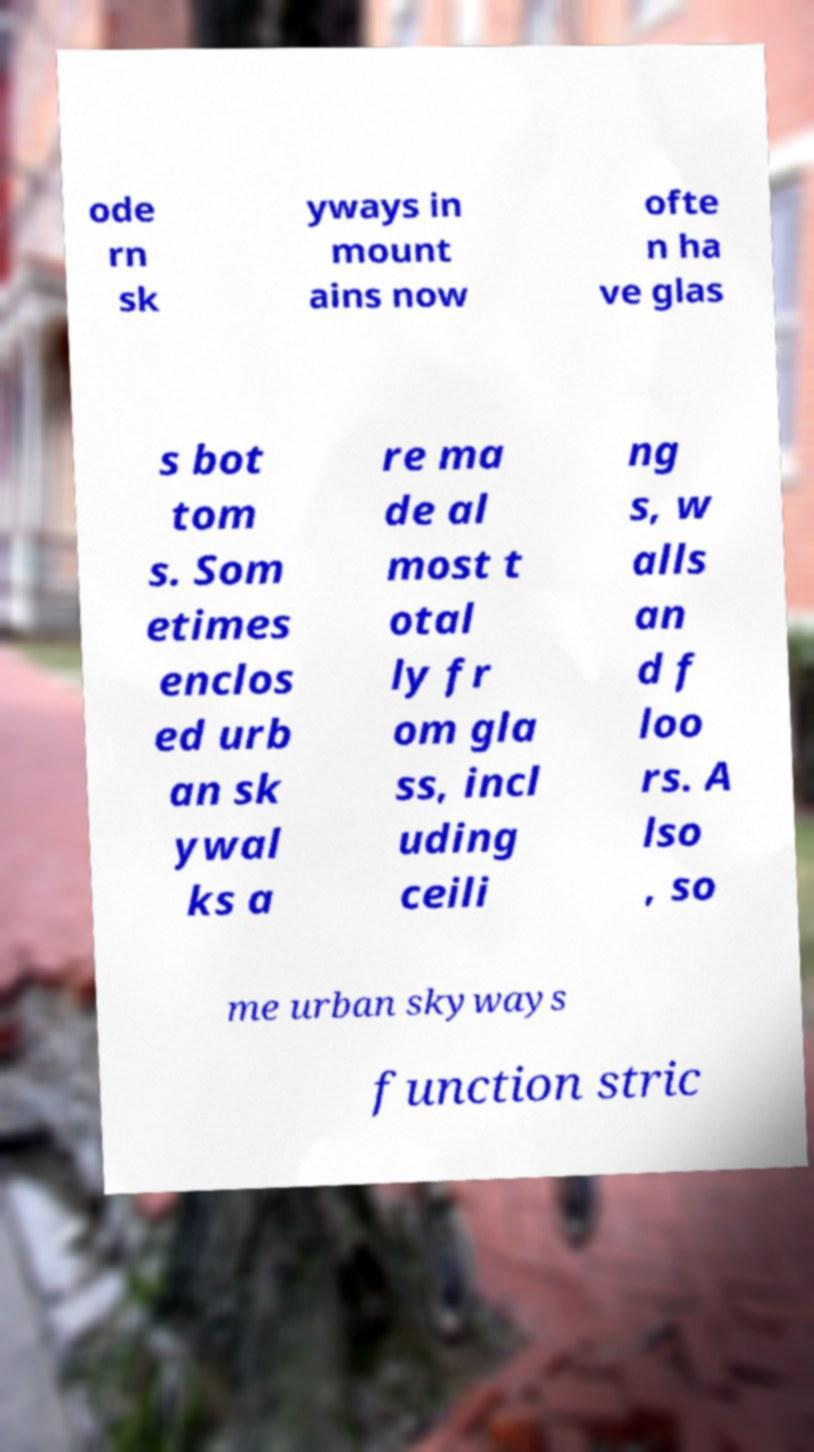Please identify and transcribe the text found in this image. ode rn sk yways in mount ains now ofte n ha ve glas s bot tom s. Som etimes enclos ed urb an sk ywal ks a re ma de al most t otal ly fr om gla ss, incl uding ceili ng s, w alls an d f loo rs. A lso , so me urban skyways function stric 